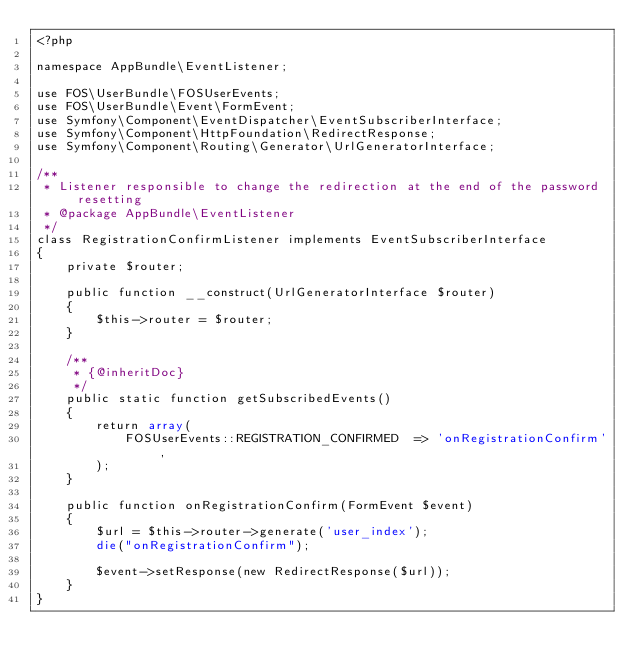<code> <loc_0><loc_0><loc_500><loc_500><_PHP_><?php

namespace AppBundle\EventListener;

use FOS\UserBundle\FOSUserEvents;
use FOS\UserBundle\Event\FormEvent;
use Symfony\Component\EventDispatcher\EventSubscriberInterface;
use Symfony\Component\HttpFoundation\RedirectResponse;
use Symfony\Component\Routing\Generator\UrlGeneratorInterface;

/**
 * Listener responsible to change the redirection at the end of the password resetting
 * @package AppBundle\EventListener
 */
class RegistrationConfirmListener implements EventSubscriberInterface
{
    private $router;

    public function __construct(UrlGeneratorInterface $router)
    {
        $this->router = $router;
    }

    /**
     * {@inheritDoc}
     */
    public static function getSubscribedEvents()
    {
        return array(
            FOSUserEvents::REGISTRATION_CONFIRMED  => 'onRegistrationConfirm',
        );
    }

    public function onRegistrationConfirm(FormEvent $event)
    {
        $url = $this->router->generate('user_index');
        die("onRegistrationConfirm");
        
        $event->setResponse(new RedirectResponse($url));
    }
}</code> 